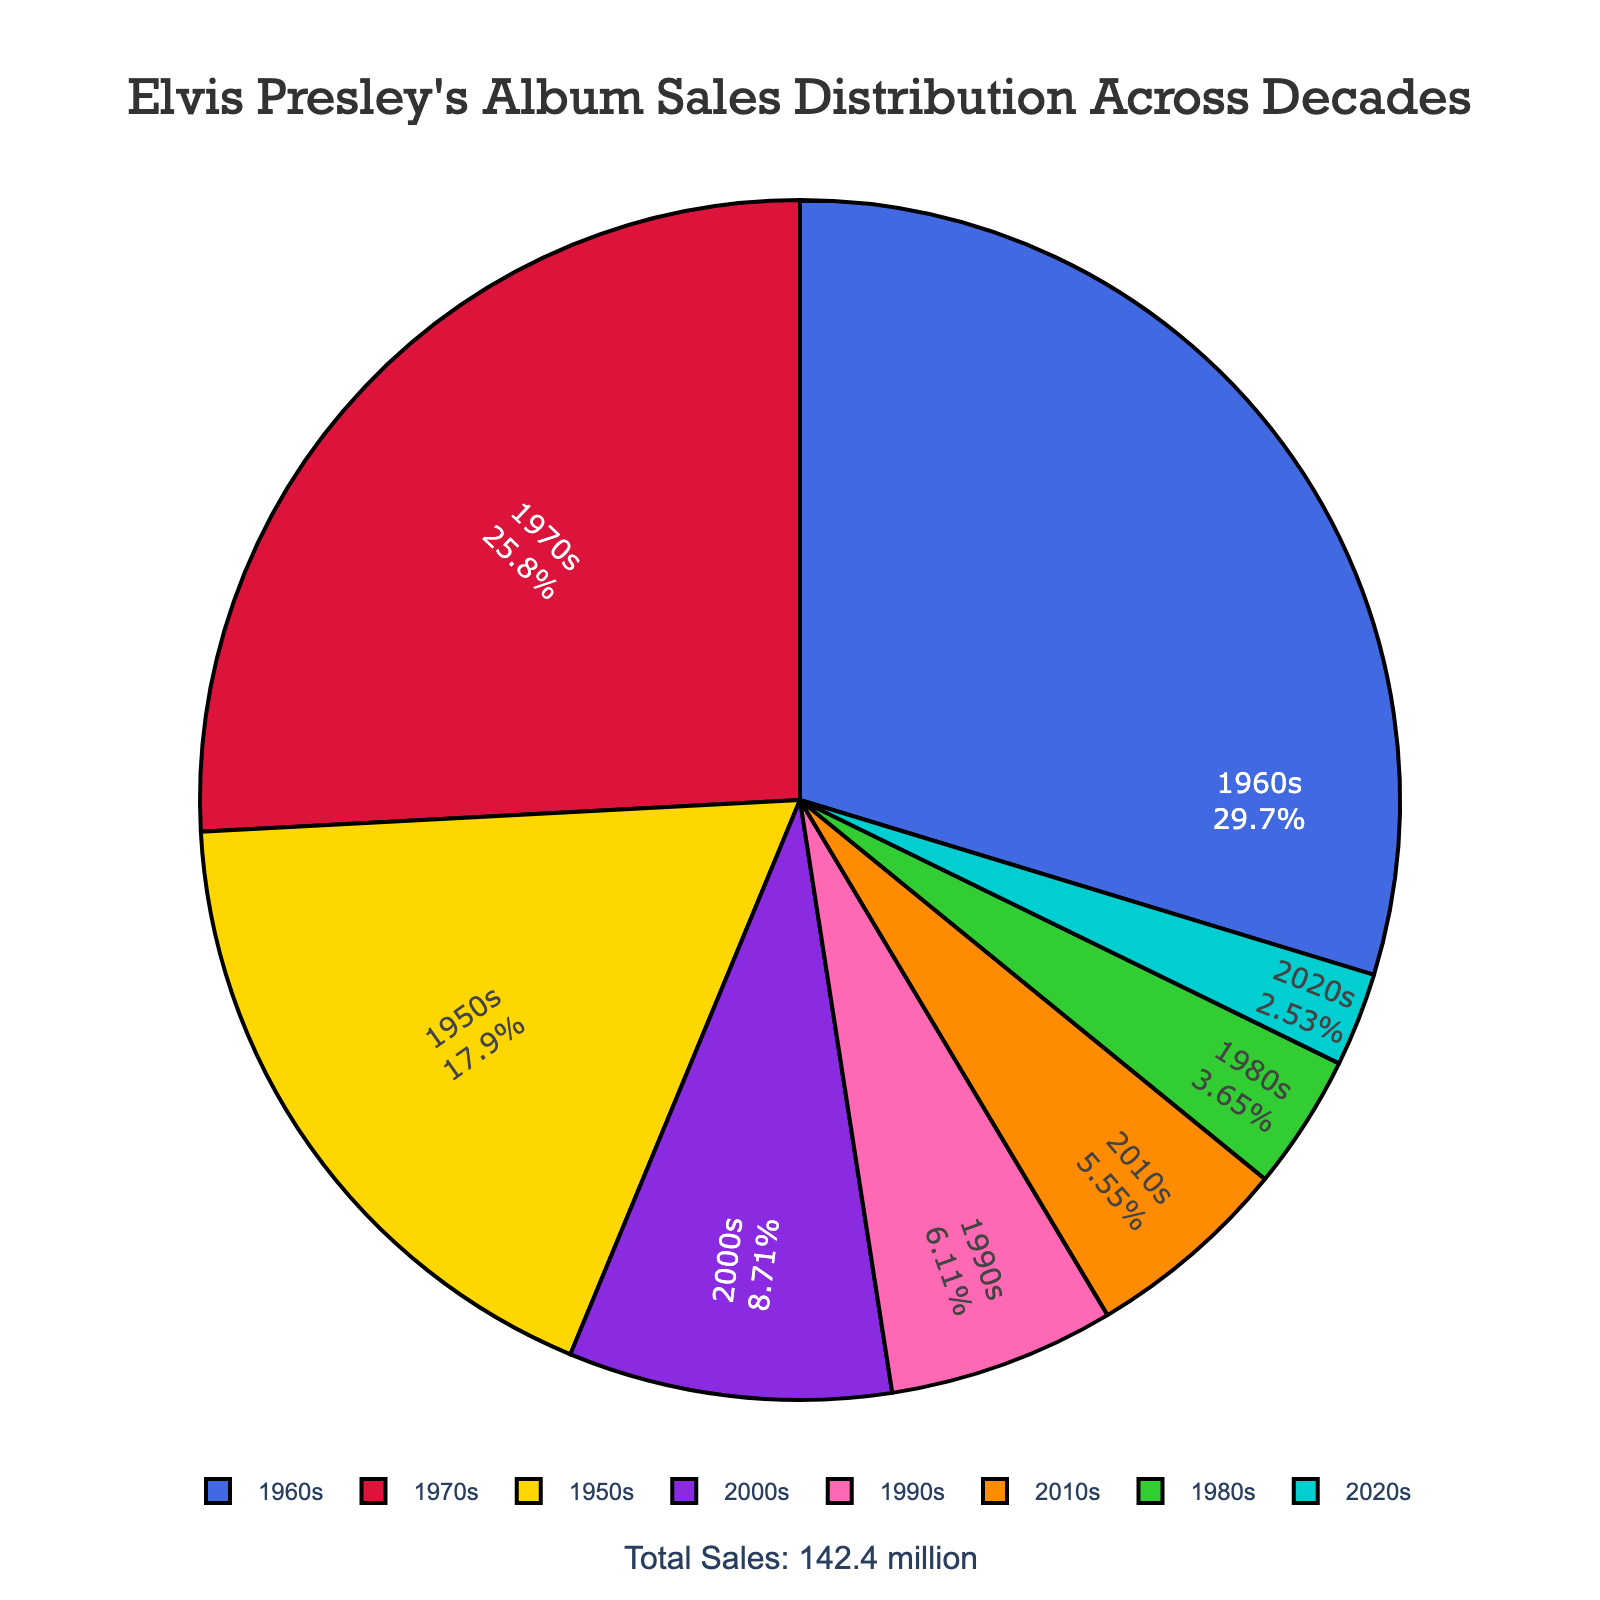What decade had the highest album sales? The pie chart shows that the 1960s segment is the largest, indicating the highest sales.
Answer: 1960s Which two decades combined account for the highest album sales? Adding the album sales of each decade from the chart, the combined sales of the 1960s (42.3 million) and 1970s (36.8 million) are higher compared to any other combination.
Answer: 1960s and 1970s How much higher are the album sales in the 1960s compared to the 1980s? The 1960s had 42.3 million in album sales, and the 1980s had 5.2 million. The difference is 42.3 - 5.2 = 37.1 million.
Answer: 37.1 million What's the total percentage of album sales for the 1950s and 2000s combined? Add the percentages of the 1950s (12.5%) and 2000s (12.4%), which are visually shown in the chart.
Answer: 24.9% Which decade had the smallest contribution to total album sales? The smallest pie segment is for the 2020s decade.
Answer: 2020s How do album sales in the 2010s compare to the 1990s? The pie chart indicates sales of 8.7 million for the 1990s and 7.9 million for the 2010s. The 1990s had higher sales by 0.8 million.
Answer: 1990s were higher What is the average album sales per decade? Summing the album sales across all decades and dividing by the number of decades (8): Total sales = 142.4 million, Average = 142.4 / 8
Answer: 17.8 million What percentage of the total sales occurred before 1980? Summing the album sales from the 1950s, 1960s, and 1970s (25.5 + 42.3 + 36.8 = 104.6 million) and dividing by the total (142.4 million), then multiplying by 100. The percentage is approximately 73.5%.
Answer: 73.5% Which color represents the 1950s decade in the pie chart? Noting the custom color legend, the 1950s segment with 25.5 million sales is in gold.
Answer: Gold 